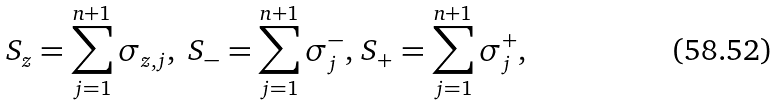Convert formula to latex. <formula><loc_0><loc_0><loc_500><loc_500>S _ { z } = \sum _ { j = 1 } ^ { n + 1 } \sigma _ { z , j } , \text {\ } S _ { - } = \sum _ { j = 1 } ^ { n + 1 } \sigma _ { j } ^ { - } , \, S _ { + } = \sum _ { j = 1 } ^ { n + 1 } \sigma _ { j } ^ { + } ,</formula> 